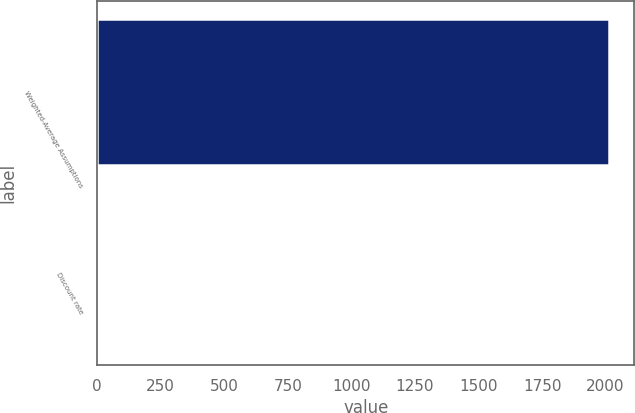Convert chart. <chart><loc_0><loc_0><loc_500><loc_500><bar_chart><fcel>Weighted-Average Assumptions<fcel>Discount rate<nl><fcel>2013<fcel>4.31<nl></chart> 